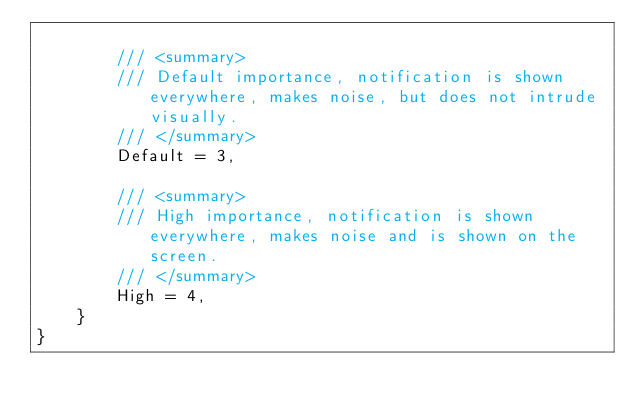<code> <loc_0><loc_0><loc_500><loc_500><_C#_>
        /// <summary>
        /// Default importance, notification is shown everywhere, makes noise, but does not intrude visually.
        /// </summary>
        Default = 3,

        /// <summary>
        /// High importance, notification is shown everywhere, makes noise and is shown on the screen.
        /// </summary>
        High = 4,
    }
}</code> 